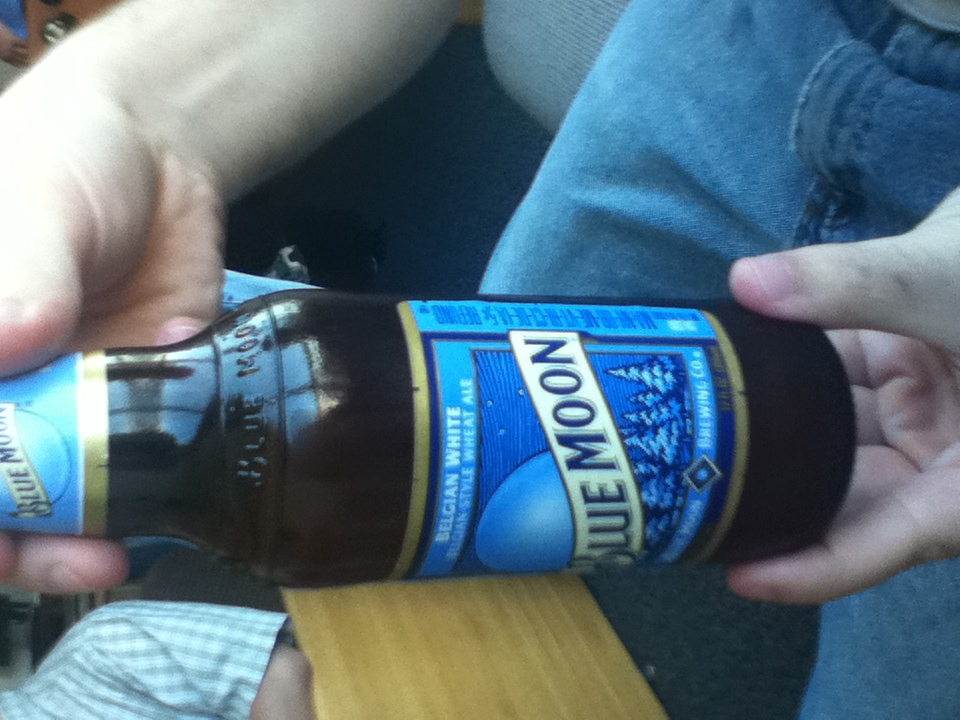What kind of beer is this? The beer shown in the image is Blue Moon, a popular Belgian White style wheat ale known for its smooth and crisp taste with notes of orange peel and coriander. It is often served with a slice of orange to accentuate its citrus flavor profile. 